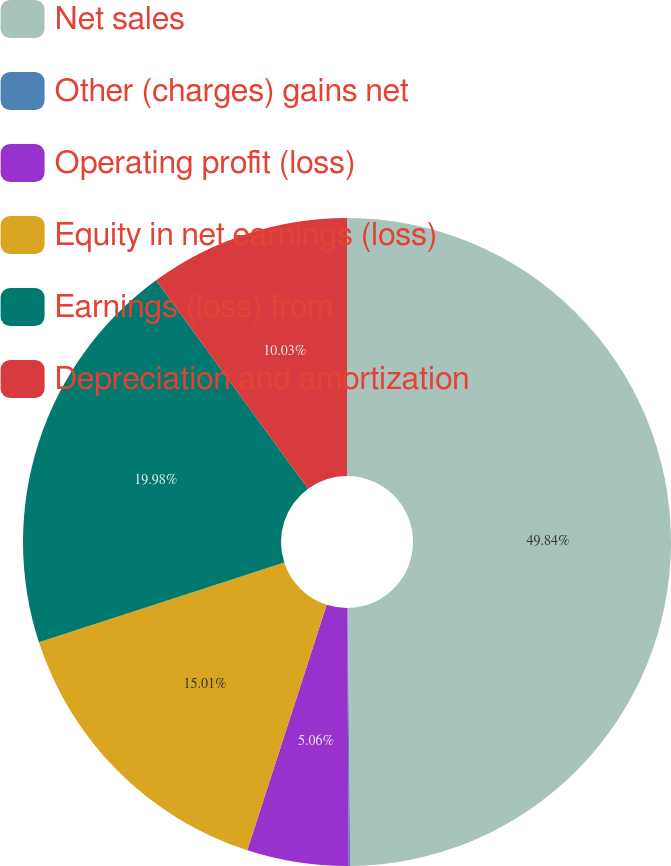Convert chart. <chart><loc_0><loc_0><loc_500><loc_500><pie_chart><fcel>Net sales<fcel>Other (charges) gains net<fcel>Operating profit (loss)<fcel>Equity in net earnings (loss)<fcel>Earnings (loss) from<fcel>Depreciation and amortization<nl><fcel>49.84%<fcel>0.08%<fcel>5.06%<fcel>15.01%<fcel>19.98%<fcel>10.03%<nl></chart> 